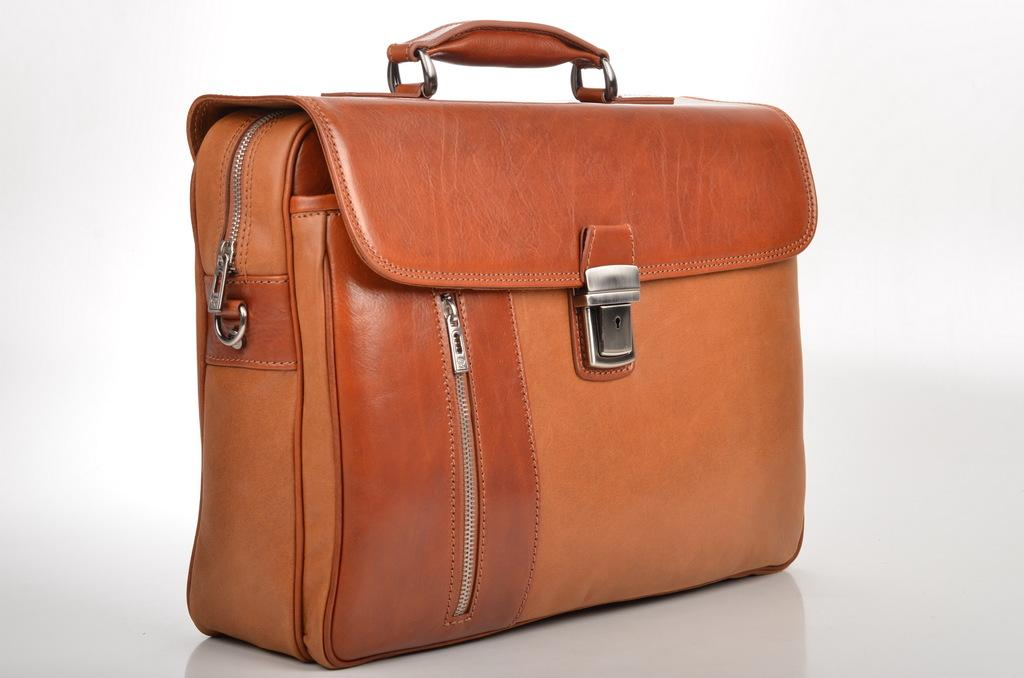What color is the bag that is visible in the image? There is an orange color bag in the image. Reasoning: Let' Let's think step by step in order to produce the conversation. We start by identifying the main subject in the image, which is the orange color bag. Then, we formulate a question that focuses on the color of the bag, ensuring that the language is simple and clear. We avoid yes/no questions and ensure that the question can be answered definitively with the information given. Absurd Question/Answer: Can you see a cat nesting in the orange color bag in the image? There is no cat or nest present in the image; it only features an orange color bag. What is the relation between the orange color bag and the nest in the image? There is no nest present in the image, and therefore no relation can be established between the orange color bag and a nest. 